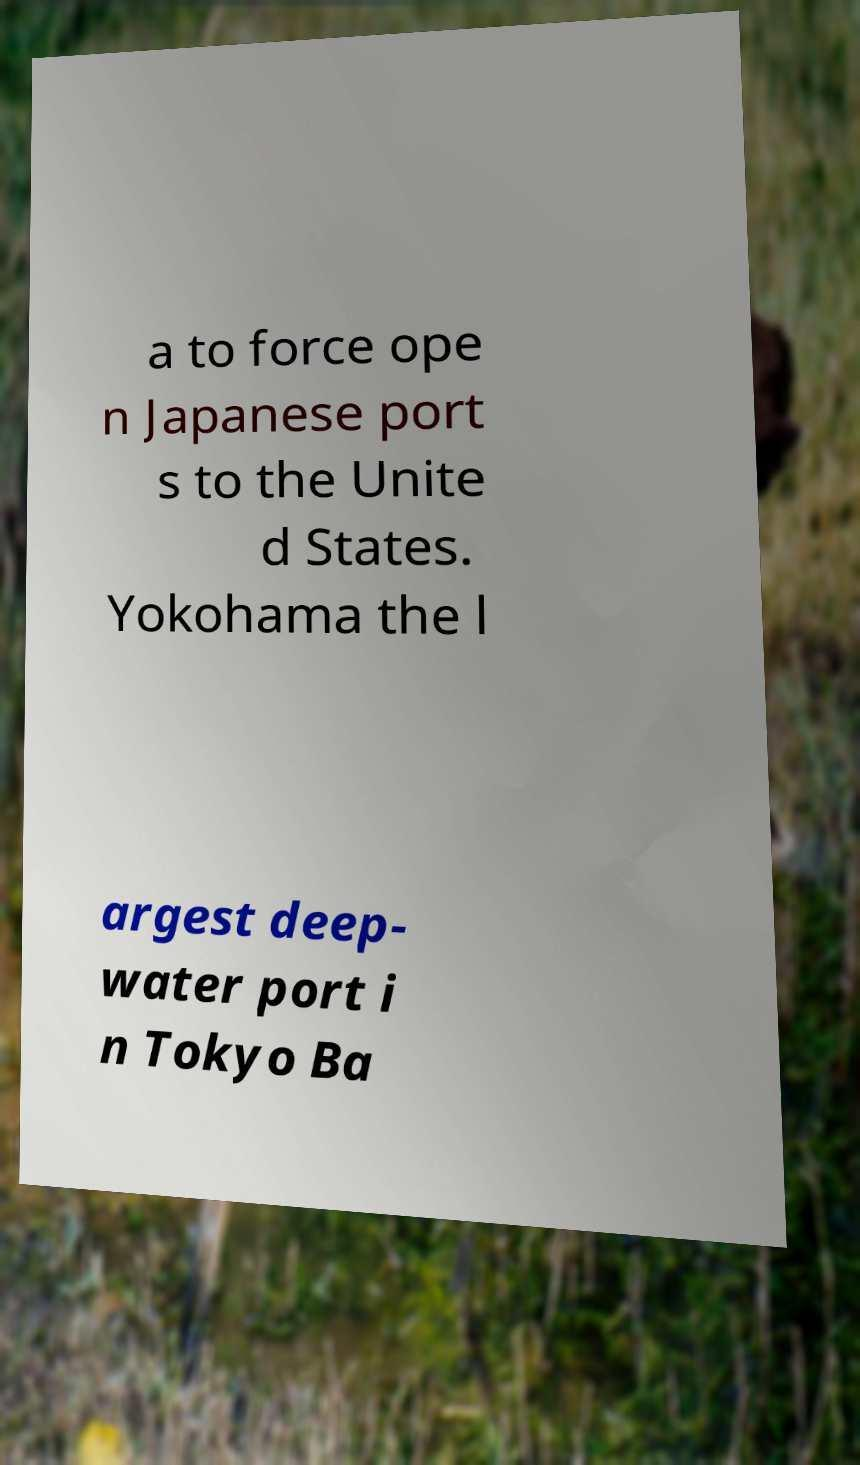For documentation purposes, I need the text within this image transcribed. Could you provide that? a to force ope n Japanese port s to the Unite d States. Yokohama the l argest deep- water port i n Tokyo Ba 